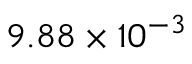<formula> <loc_0><loc_0><loc_500><loc_500>9 . 8 8 \times 1 0 ^ { - 3 }</formula> 